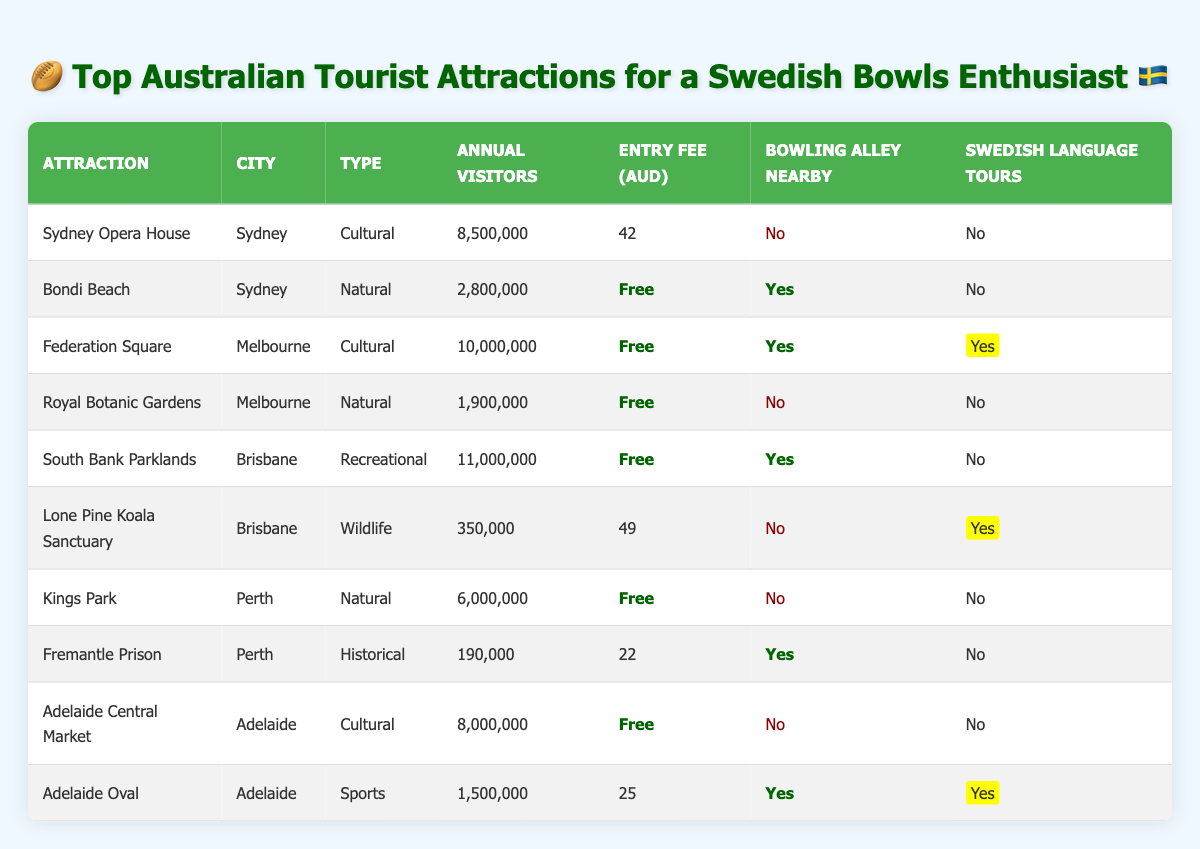What is the entry fee for the Sydney Opera House? The table lists the entry fee for the Sydney Opera House under the "Entry Fee (AUD)" column, which shows 42 AUD.
Answer: 42 AUD Which attraction has the highest annual visitors? Looking at the "Annual Visitors" column, Federation Square has the highest count at 10,000,000.
Answer: Federation Square Do any attractions offer Swedish language tours? To find this, we check the "Swedish Language Tours" column. Both Federation Square and Lone Pine Koala Sanctuary indicate "Yes".
Answer: Yes What is the average entry fee for all attractions listed? First, we list the entry fees: 42, 0, 0, 0, 0, 49, 0, 22, 0, 25. Adding these gives 138, and dividing by 10 attractions gives 13.8.
Answer: 13.8 AUD How many attractions in Brisbane have bowling alleys nearby? Checking the "Bowling Alley Nearby" column for Brisbane's attractions, South Bank Parklands shows "Yes" and Lone Pine Koala Sanctuary shows "No". So, there's only one attraction with a bowling alley.
Answer: 1 What is the total number of annual visitors for attractions with free entry? We locate the attractions with "Free" under "Entry Fee". Those are Bondi Beach, Federation Square, Royal Botanic Gardens, South Bank Parklands, Kings Park, and Adelaide Central Market. Their visitor counts are 2,800,000, 10,000,000, 1,900,000, 11,000,000, 6,000,000, and 8,000,000 respectively. Adding these gives a total of 40,700,000.
Answer: 40,700,000 Is there an attraction that has both a bowling alley nearby and offers Swedish language tours? We check the "Bowling Alley Nearby" and "Swedish Language Tours" columns for combinations. Only Adelaide Oval satisfies both conditions.
Answer: Yes Which city has the least number of annual visitors for its major attractions? We compare total annual visitors across attractions in each city: Sydney (8,500,000 + 2,800,000), Melbourne (10,000,000 + 1,900,000), Brisbane (11,000,000 + 350,000), Perth (6,000,000 + 190,000), and Adelaide (8,000,000 + 1,500,000). Perth has the least with 6,190,000.
Answer: Perth 